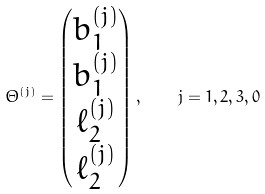Convert formula to latex. <formula><loc_0><loc_0><loc_500><loc_500>\Theta ^ { ( j ) } = \begin{pmatrix} b ^ { ( j ) } _ { 1 } \\ b ^ { ( j ) } _ { 1 } \\ \ell ^ { ( j ) } _ { 2 } \\ \ell ^ { ( j ) } _ { 2 } \end{pmatrix} , \quad j = 1 , 2 , 3 , 0</formula> 